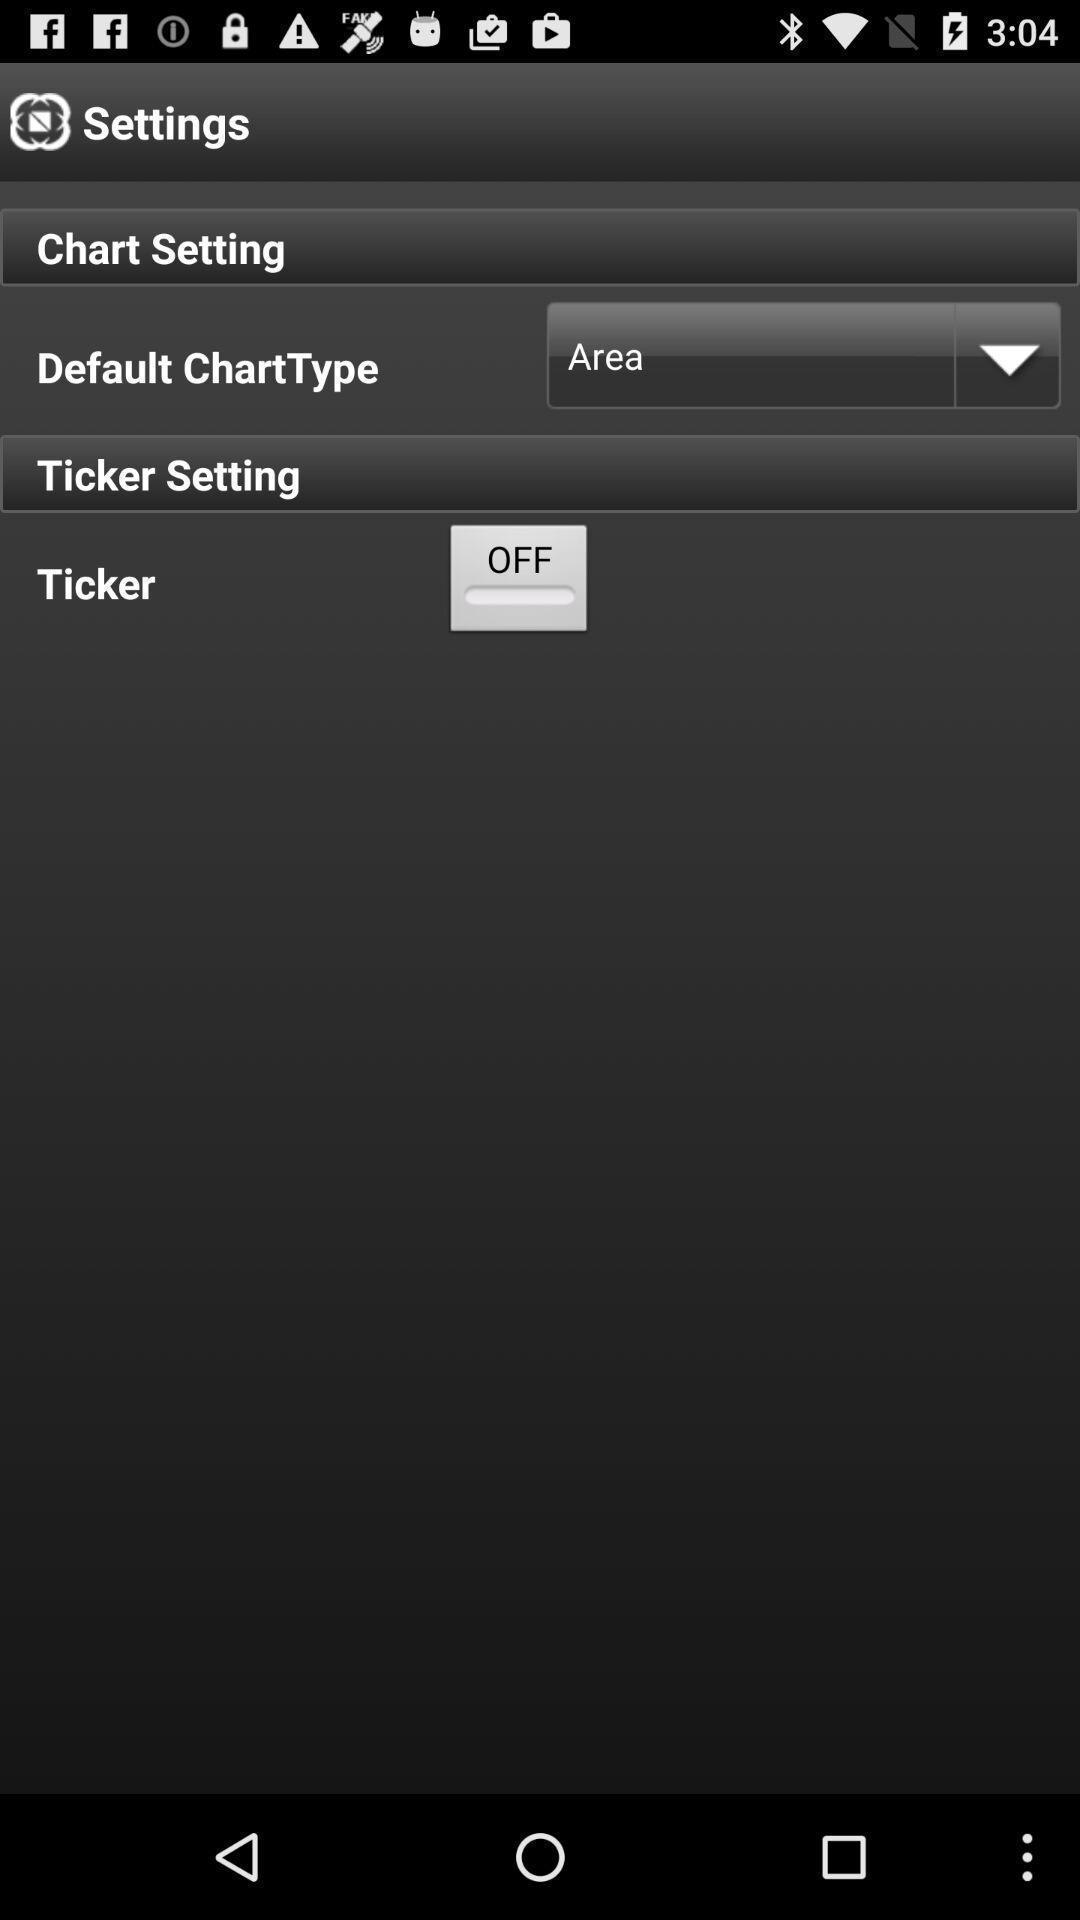Summarize the information in this screenshot. Screen displaying multiple setting options. 